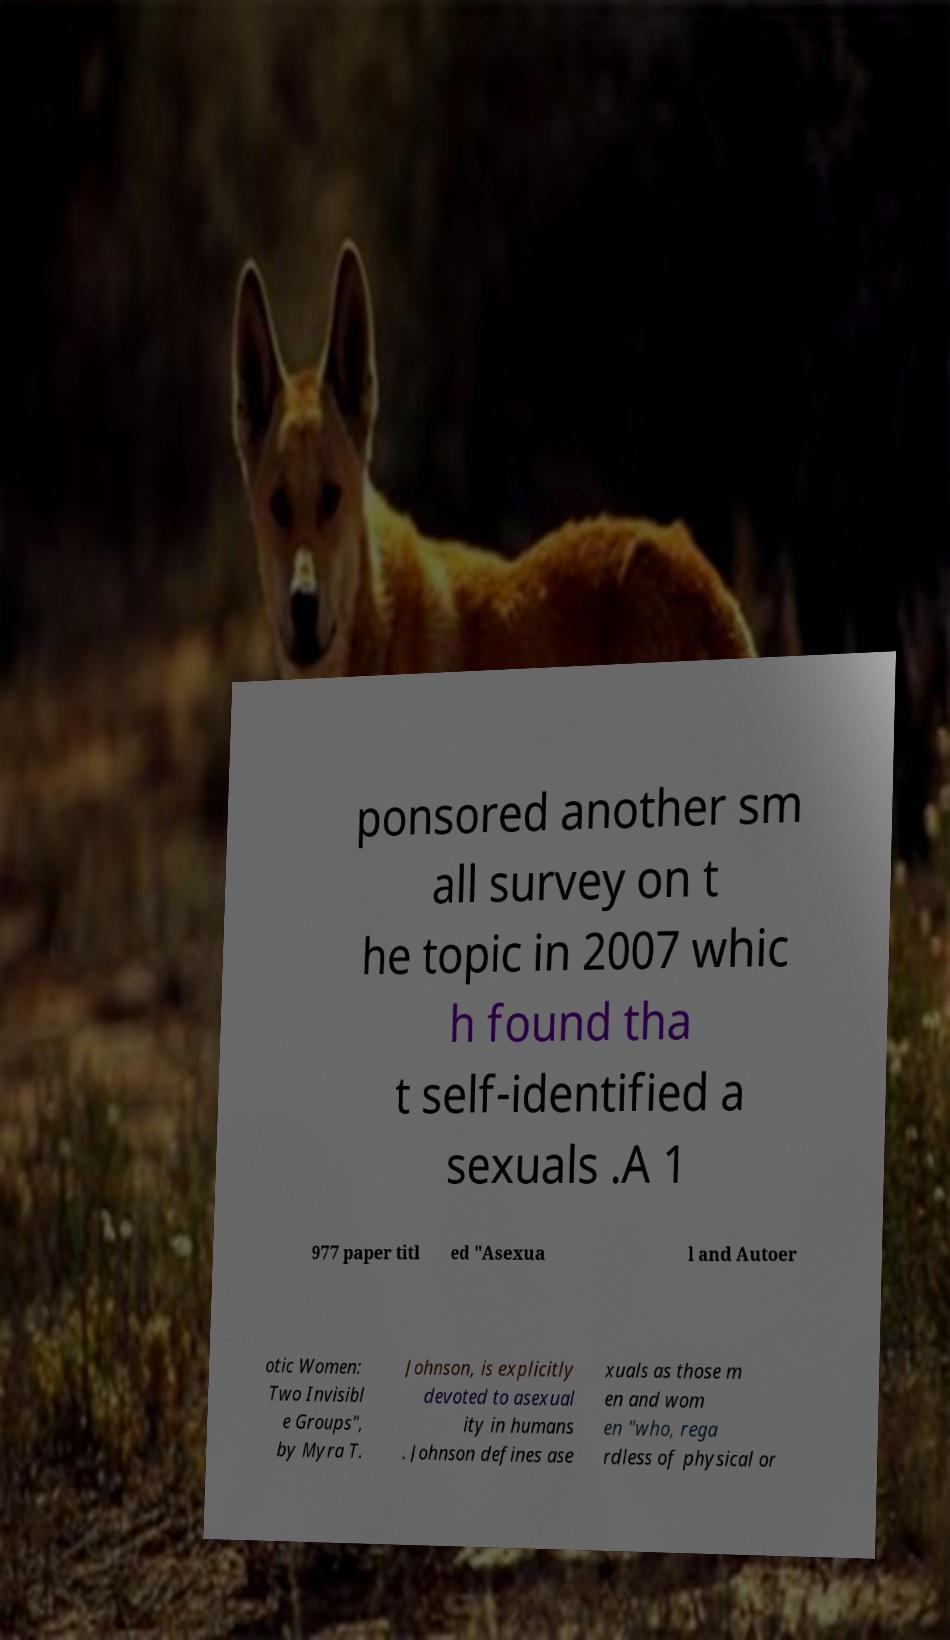What messages or text are displayed in this image? I need them in a readable, typed format. ponsored another sm all survey on t he topic in 2007 whic h found tha t self-identified a sexuals .A 1 977 paper titl ed "Asexua l and Autoer otic Women: Two Invisibl e Groups", by Myra T. Johnson, is explicitly devoted to asexual ity in humans . Johnson defines ase xuals as those m en and wom en "who, rega rdless of physical or 